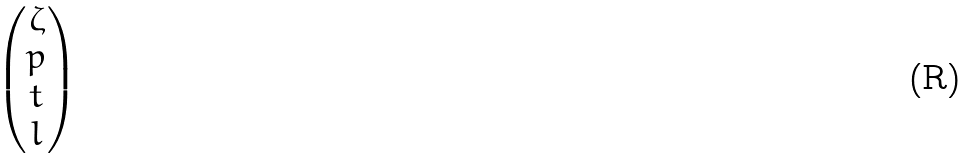<formula> <loc_0><loc_0><loc_500><loc_500>\begin{pmatrix} \zeta \\ p \\ t \\ l \end{pmatrix}</formula> 